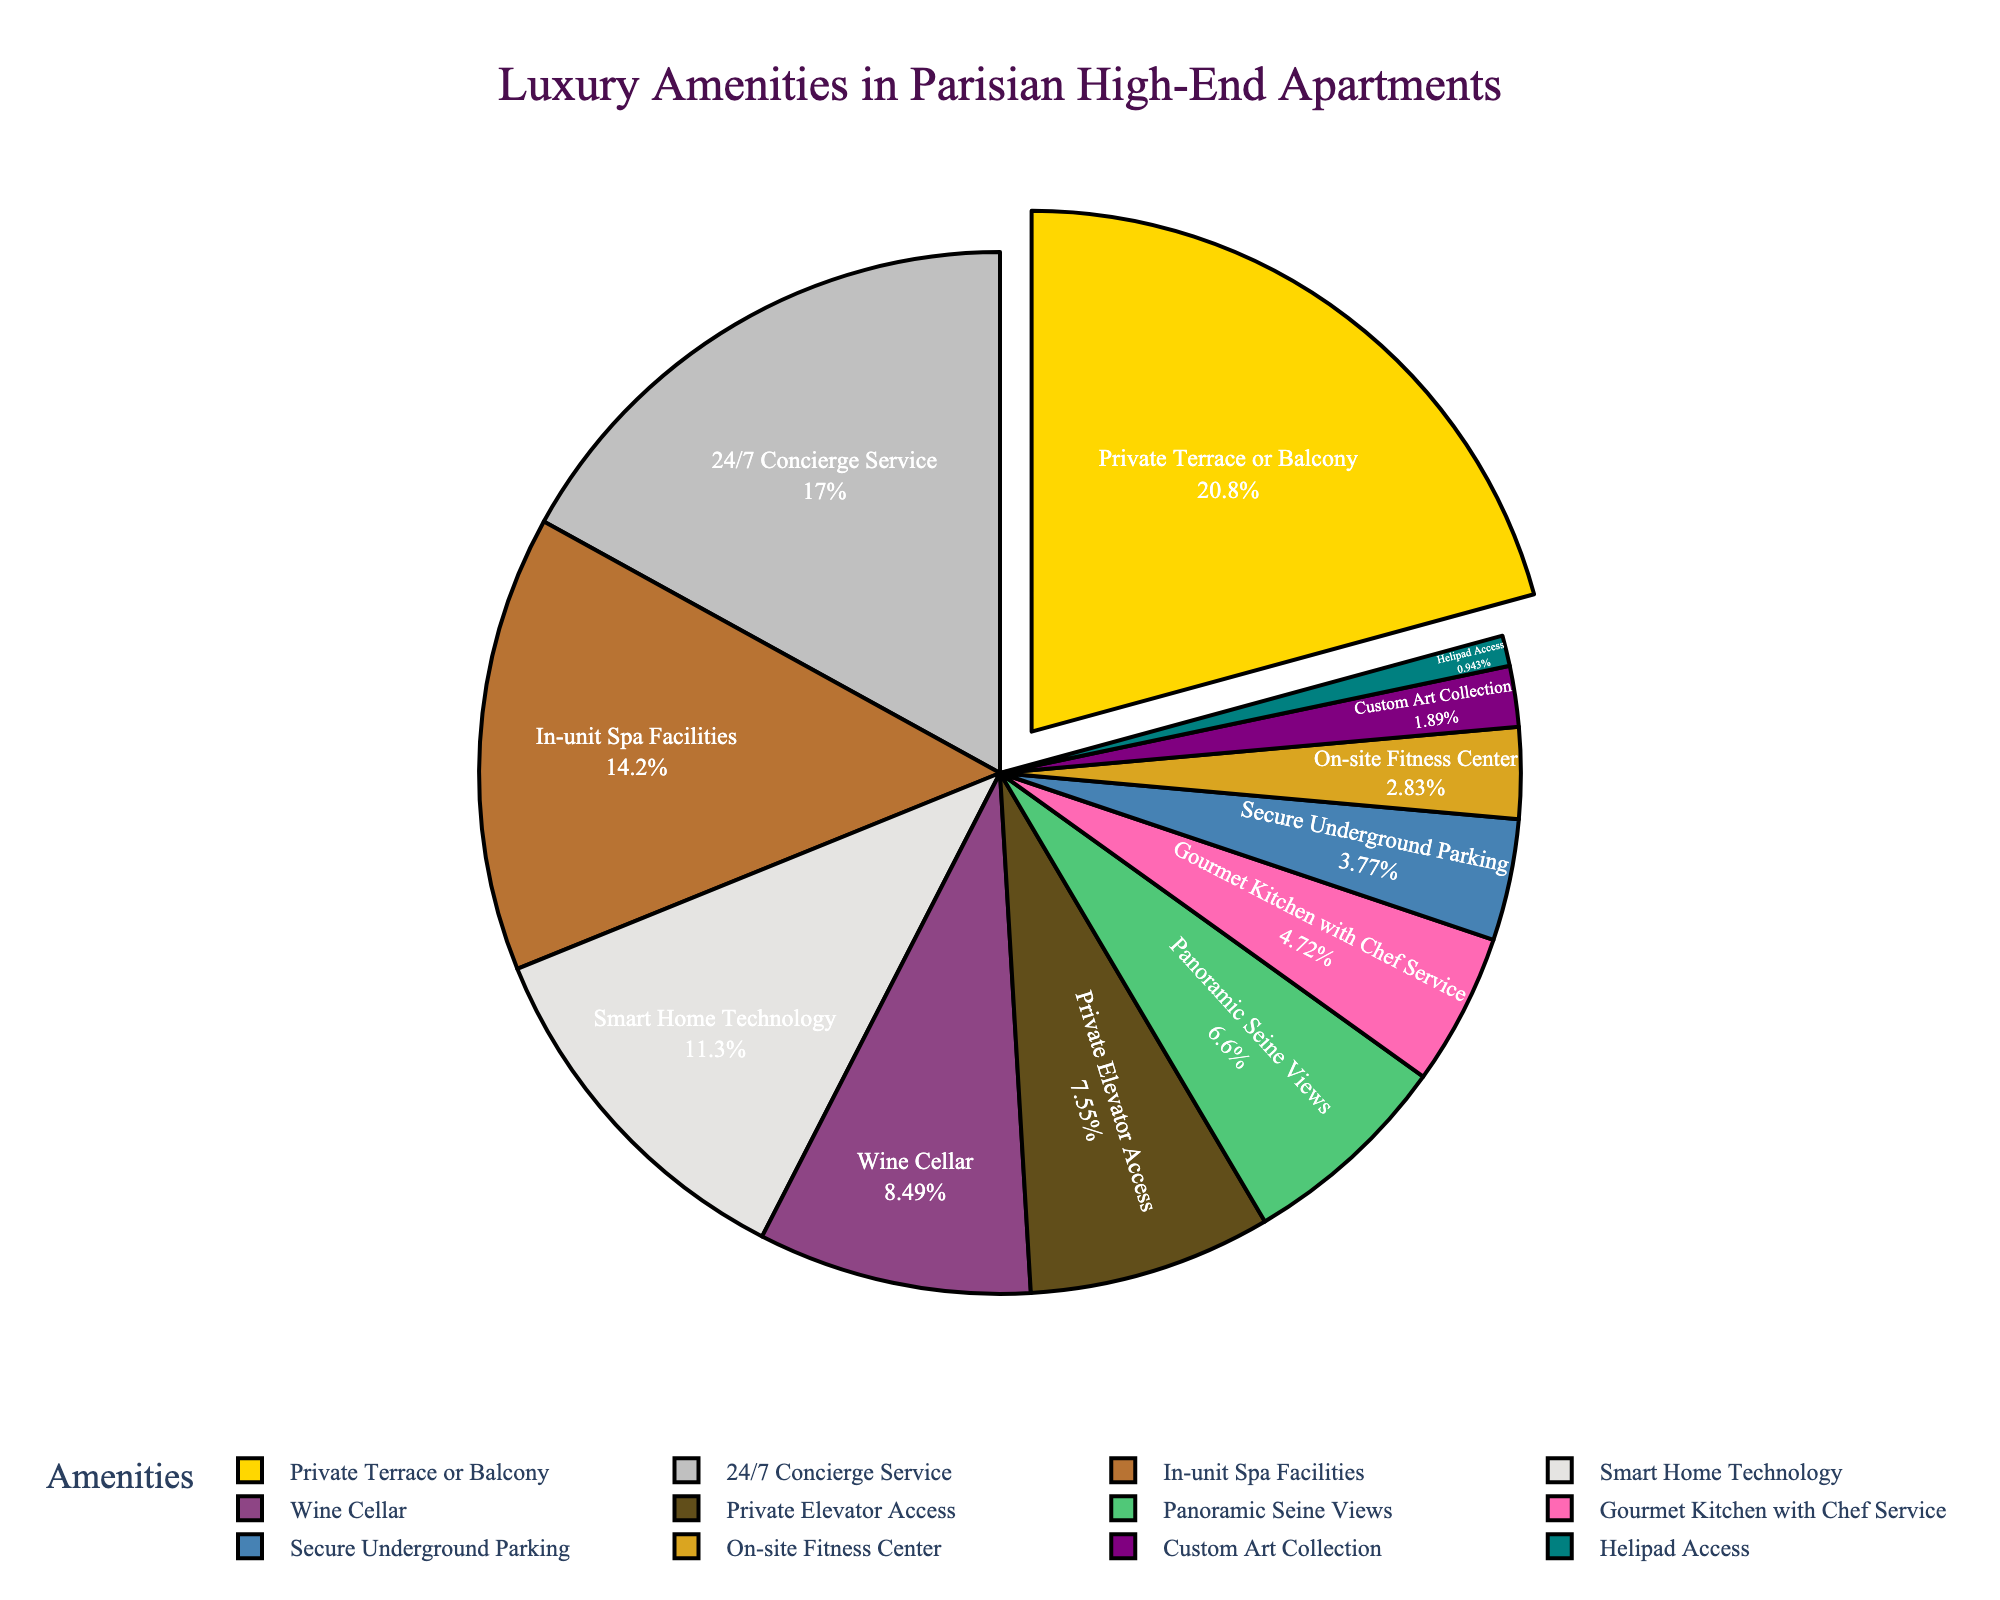What's the most common amenity offered in high-end Parisian apartments? The pie chart shows the "Private Terrace or Balcony" segment as the largest piece of the pie, indicating that it's the most common amenity.
Answer: Private Terrace or Balcony Which amenity is offered less frequently, "Wine Cellar" or "Custom Art Collection"? By comparing the sizes of the pie segments, "Custom Art Collection" occupies a smaller percentage (2%) than "Wine Cellar" (9%). Therefore, "Custom Art Collection" is offered less frequently.
Answer: Custom Art Collection What is the combined percentage of apartments that offer "24/7 Concierge Service" and "In-unit Spa Facilities"? There are two steps here: First, identify the percentage for each amenity. "24/7 Concierge Service" is 18% and "In-unit Spa Facilities" is 15%. Second, add these two percentages together: 18% + 15% = 33%.
Answer: 33% Are more apartments equipped with "Smart Home Technology" or "Gourmet Kitchen with Chef Service"? From the pie chart, "Smart Home Technology" has a percentage of 12%, while "Gourmet Kitchen with Chef Service" has a percentage of 5%. Therefore, more apartments are equipped with "Smart Home Technology."
Answer: Smart Home Technology What is the difference in percentage between "Private Terrace or Balcony" and "Panoramic Seine Views"? Identify the percentages from the chart: "Private Terrace or Balcony" is 22% and "Panoramic Seine Views" is 7%. Subtract the smaller from the larger: 22% - 7% = 15%.
Answer: 15% What percentage of high-end Parisian apartments offer amenities related to relaxation and leisure (sum of "In-unit Spa Facilities" and "Wine Cellar")? Identify the relevant percentages: "In-unit Spa Facilities" is 15% and "Wine Cellar" is 9%. Add these percentages together: 15% + 9% = 24%.
Answer: 24% Which amenities have a combined percentage of less than 10%? Identify each segment with a percentage and add them to see if they are less than 10%. "Secure Underground Parking" (4%), "On-site Fitness Center" (3%), "Custom Art Collection" (2%), and "Helipad Access" (1%) have a combined percentage of 4% + 3% + 2% + 1% = 10%, hence none of them individually are less than 10% combined. However, individually each one of them is less than 10%.
Answer: Secure Underground Parking, On-site Fitness Center, Custom Art Collection, Helipad Access Which two amenities together make up almost one-quarter of all amenities offered? Identify the amenities with percentages that, when summed, equal roughly 25%. "Private Terrace or Balcony" is 22% and "Helipad Access" is 1%. Together, they add up to 22% + 1% = 23%, but not quite 25%. Trying another combination: "24/7 Concierge Service" is 18% and "Panoramic Seine Views" is 7%. Together they add up to 18% + 7% = 25%.
Answer: 24/7 Concierge Service and Panoramic Seine Views Which amenity is represented by the color gold in the chart? According to the custom color palette, '#FFD700' is gold. Referring to the order of colors and amenities, the first one ("Private Terrace or Balcony") is represented by the color gold.
Answer: Private Terrace or Balcony 